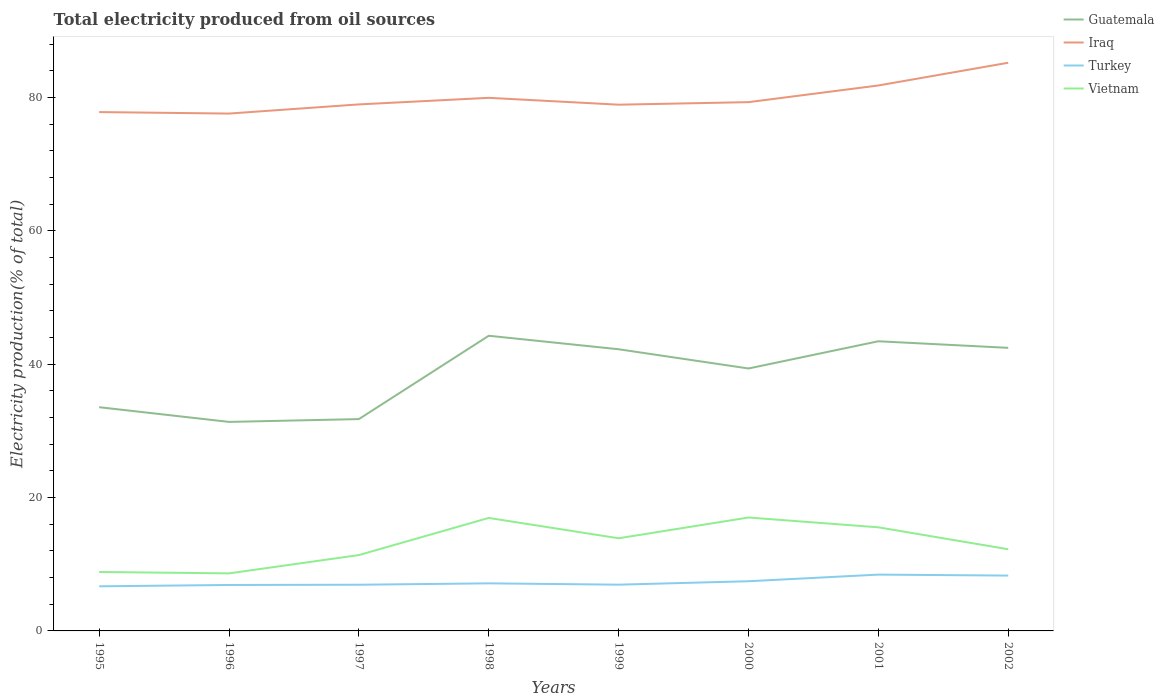How many different coloured lines are there?
Make the answer very short. 4. Is the number of lines equal to the number of legend labels?
Provide a succinct answer. Yes. Across all years, what is the maximum total electricity produced in Guatemala?
Offer a very short reply. 31.36. In which year was the total electricity produced in Guatemala maximum?
Provide a succinct answer. 1996. What is the total total electricity produced in Guatemala in the graph?
Ensure brevity in your answer.  -0.21. What is the difference between the highest and the second highest total electricity produced in Vietnam?
Offer a very short reply. 8.38. How many lines are there?
Your answer should be compact. 4. How many years are there in the graph?
Your answer should be very brief. 8. Are the values on the major ticks of Y-axis written in scientific E-notation?
Offer a very short reply. No. Does the graph contain grids?
Give a very brief answer. No. How are the legend labels stacked?
Offer a terse response. Vertical. What is the title of the graph?
Your answer should be very brief. Total electricity produced from oil sources. What is the label or title of the X-axis?
Offer a terse response. Years. What is the Electricity production(% of total) in Guatemala in 1995?
Your answer should be very brief. 33.56. What is the Electricity production(% of total) in Iraq in 1995?
Make the answer very short. 77.83. What is the Electricity production(% of total) in Turkey in 1995?
Your answer should be compact. 6.69. What is the Electricity production(% of total) in Vietnam in 1995?
Provide a short and direct response. 8.84. What is the Electricity production(% of total) of Guatemala in 1996?
Make the answer very short. 31.36. What is the Electricity production(% of total) of Iraq in 1996?
Provide a succinct answer. 77.61. What is the Electricity production(% of total) in Turkey in 1996?
Provide a short and direct response. 6.89. What is the Electricity production(% of total) in Vietnam in 1996?
Provide a short and direct response. 8.63. What is the Electricity production(% of total) in Guatemala in 1997?
Offer a very short reply. 31.78. What is the Electricity production(% of total) in Iraq in 1997?
Your answer should be compact. 78.98. What is the Electricity production(% of total) of Turkey in 1997?
Your answer should be compact. 6.93. What is the Electricity production(% of total) in Vietnam in 1997?
Your answer should be very brief. 11.38. What is the Electricity production(% of total) of Guatemala in 1998?
Give a very brief answer. 44.28. What is the Electricity production(% of total) of Iraq in 1998?
Offer a terse response. 79.97. What is the Electricity production(% of total) of Turkey in 1998?
Your response must be concise. 7.14. What is the Electricity production(% of total) in Vietnam in 1998?
Provide a short and direct response. 16.95. What is the Electricity production(% of total) in Guatemala in 1999?
Keep it short and to the point. 42.25. What is the Electricity production(% of total) of Iraq in 1999?
Your response must be concise. 78.94. What is the Electricity production(% of total) of Turkey in 1999?
Keep it short and to the point. 6.94. What is the Electricity production(% of total) in Vietnam in 1999?
Provide a succinct answer. 13.9. What is the Electricity production(% of total) of Guatemala in 2000?
Your answer should be very brief. 39.37. What is the Electricity production(% of total) in Iraq in 2000?
Ensure brevity in your answer.  79.32. What is the Electricity production(% of total) of Turkey in 2000?
Offer a terse response. 7.45. What is the Electricity production(% of total) of Vietnam in 2000?
Your answer should be compact. 17.01. What is the Electricity production(% of total) in Guatemala in 2001?
Offer a very short reply. 43.45. What is the Electricity production(% of total) of Iraq in 2001?
Your answer should be very brief. 81.82. What is the Electricity production(% of total) in Turkey in 2001?
Provide a short and direct response. 8.45. What is the Electricity production(% of total) of Vietnam in 2001?
Offer a terse response. 15.54. What is the Electricity production(% of total) in Guatemala in 2002?
Ensure brevity in your answer.  42.46. What is the Electricity production(% of total) in Iraq in 2002?
Keep it short and to the point. 85.23. What is the Electricity production(% of total) in Turkey in 2002?
Make the answer very short. 8.3. What is the Electricity production(% of total) in Vietnam in 2002?
Provide a succinct answer. 12.25. Across all years, what is the maximum Electricity production(% of total) of Guatemala?
Ensure brevity in your answer.  44.28. Across all years, what is the maximum Electricity production(% of total) in Iraq?
Your answer should be compact. 85.23. Across all years, what is the maximum Electricity production(% of total) in Turkey?
Keep it short and to the point. 8.45. Across all years, what is the maximum Electricity production(% of total) of Vietnam?
Keep it short and to the point. 17.01. Across all years, what is the minimum Electricity production(% of total) of Guatemala?
Offer a very short reply. 31.36. Across all years, what is the minimum Electricity production(% of total) of Iraq?
Give a very brief answer. 77.61. Across all years, what is the minimum Electricity production(% of total) in Turkey?
Offer a very short reply. 6.69. Across all years, what is the minimum Electricity production(% of total) of Vietnam?
Provide a short and direct response. 8.63. What is the total Electricity production(% of total) of Guatemala in the graph?
Provide a succinct answer. 308.51. What is the total Electricity production(% of total) of Iraq in the graph?
Provide a succinct answer. 639.72. What is the total Electricity production(% of total) in Turkey in the graph?
Offer a terse response. 58.79. What is the total Electricity production(% of total) of Vietnam in the graph?
Keep it short and to the point. 104.51. What is the difference between the Electricity production(% of total) in Guatemala in 1995 and that in 1996?
Provide a succinct answer. 2.2. What is the difference between the Electricity production(% of total) in Iraq in 1995 and that in 1996?
Your response must be concise. 0.22. What is the difference between the Electricity production(% of total) in Turkey in 1995 and that in 1996?
Offer a terse response. -0.2. What is the difference between the Electricity production(% of total) of Vietnam in 1995 and that in 1996?
Your answer should be compact. 0.21. What is the difference between the Electricity production(% of total) of Guatemala in 1995 and that in 1997?
Keep it short and to the point. 1.78. What is the difference between the Electricity production(% of total) of Iraq in 1995 and that in 1997?
Offer a terse response. -1.15. What is the difference between the Electricity production(% of total) of Turkey in 1995 and that in 1997?
Provide a succinct answer. -0.24. What is the difference between the Electricity production(% of total) in Vietnam in 1995 and that in 1997?
Provide a succinct answer. -2.54. What is the difference between the Electricity production(% of total) of Guatemala in 1995 and that in 1998?
Make the answer very short. -10.72. What is the difference between the Electricity production(% of total) of Iraq in 1995 and that in 1998?
Ensure brevity in your answer.  -2.14. What is the difference between the Electricity production(% of total) in Turkey in 1995 and that in 1998?
Provide a succinct answer. -0.44. What is the difference between the Electricity production(% of total) in Vietnam in 1995 and that in 1998?
Your response must be concise. -8.11. What is the difference between the Electricity production(% of total) of Guatemala in 1995 and that in 1999?
Your answer should be very brief. -8.69. What is the difference between the Electricity production(% of total) in Iraq in 1995 and that in 1999?
Your answer should be compact. -1.11. What is the difference between the Electricity production(% of total) of Turkey in 1995 and that in 1999?
Make the answer very short. -0.25. What is the difference between the Electricity production(% of total) of Vietnam in 1995 and that in 1999?
Make the answer very short. -5.06. What is the difference between the Electricity production(% of total) in Guatemala in 1995 and that in 2000?
Make the answer very short. -5.81. What is the difference between the Electricity production(% of total) of Iraq in 1995 and that in 2000?
Your answer should be compact. -1.49. What is the difference between the Electricity production(% of total) of Turkey in 1995 and that in 2000?
Your response must be concise. -0.76. What is the difference between the Electricity production(% of total) of Vietnam in 1995 and that in 2000?
Ensure brevity in your answer.  -8.17. What is the difference between the Electricity production(% of total) in Guatemala in 1995 and that in 2001?
Your answer should be compact. -9.89. What is the difference between the Electricity production(% of total) in Iraq in 1995 and that in 2001?
Your response must be concise. -3.99. What is the difference between the Electricity production(% of total) in Turkey in 1995 and that in 2001?
Offer a very short reply. -1.75. What is the difference between the Electricity production(% of total) in Vietnam in 1995 and that in 2001?
Offer a terse response. -6.7. What is the difference between the Electricity production(% of total) of Guatemala in 1995 and that in 2002?
Your answer should be very brief. -8.9. What is the difference between the Electricity production(% of total) of Iraq in 1995 and that in 2002?
Provide a succinct answer. -7.4. What is the difference between the Electricity production(% of total) of Turkey in 1995 and that in 2002?
Offer a very short reply. -1.61. What is the difference between the Electricity production(% of total) in Vietnam in 1995 and that in 2002?
Keep it short and to the point. -3.41. What is the difference between the Electricity production(% of total) in Guatemala in 1996 and that in 1997?
Ensure brevity in your answer.  -0.42. What is the difference between the Electricity production(% of total) in Iraq in 1996 and that in 1997?
Your answer should be compact. -1.37. What is the difference between the Electricity production(% of total) in Turkey in 1996 and that in 1997?
Give a very brief answer. -0.03. What is the difference between the Electricity production(% of total) of Vietnam in 1996 and that in 1997?
Provide a short and direct response. -2.74. What is the difference between the Electricity production(% of total) of Guatemala in 1996 and that in 1998?
Ensure brevity in your answer.  -12.92. What is the difference between the Electricity production(% of total) of Iraq in 1996 and that in 1998?
Your response must be concise. -2.36. What is the difference between the Electricity production(% of total) in Turkey in 1996 and that in 1998?
Your response must be concise. -0.24. What is the difference between the Electricity production(% of total) in Vietnam in 1996 and that in 1998?
Provide a succinct answer. -8.32. What is the difference between the Electricity production(% of total) in Guatemala in 1996 and that in 1999?
Provide a short and direct response. -10.9. What is the difference between the Electricity production(% of total) in Iraq in 1996 and that in 1999?
Offer a very short reply. -1.33. What is the difference between the Electricity production(% of total) in Turkey in 1996 and that in 1999?
Offer a terse response. -0.04. What is the difference between the Electricity production(% of total) of Vietnam in 1996 and that in 1999?
Your answer should be compact. -5.26. What is the difference between the Electricity production(% of total) of Guatemala in 1996 and that in 2000?
Provide a short and direct response. -8.01. What is the difference between the Electricity production(% of total) in Iraq in 1996 and that in 2000?
Your answer should be very brief. -1.71. What is the difference between the Electricity production(% of total) in Turkey in 1996 and that in 2000?
Offer a terse response. -0.56. What is the difference between the Electricity production(% of total) in Vietnam in 1996 and that in 2000?
Your answer should be very brief. -8.38. What is the difference between the Electricity production(% of total) in Guatemala in 1996 and that in 2001?
Make the answer very short. -12.1. What is the difference between the Electricity production(% of total) of Iraq in 1996 and that in 2001?
Ensure brevity in your answer.  -4.21. What is the difference between the Electricity production(% of total) in Turkey in 1996 and that in 2001?
Your answer should be compact. -1.55. What is the difference between the Electricity production(% of total) of Vietnam in 1996 and that in 2001?
Provide a succinct answer. -6.91. What is the difference between the Electricity production(% of total) of Guatemala in 1996 and that in 2002?
Ensure brevity in your answer.  -11.11. What is the difference between the Electricity production(% of total) of Iraq in 1996 and that in 2002?
Your answer should be compact. -7.62. What is the difference between the Electricity production(% of total) of Turkey in 1996 and that in 2002?
Make the answer very short. -1.41. What is the difference between the Electricity production(% of total) in Vietnam in 1996 and that in 2002?
Keep it short and to the point. -3.62. What is the difference between the Electricity production(% of total) in Guatemala in 1997 and that in 1998?
Your response must be concise. -12.5. What is the difference between the Electricity production(% of total) in Iraq in 1997 and that in 1998?
Ensure brevity in your answer.  -0.99. What is the difference between the Electricity production(% of total) in Turkey in 1997 and that in 1998?
Give a very brief answer. -0.21. What is the difference between the Electricity production(% of total) of Vietnam in 1997 and that in 1998?
Provide a short and direct response. -5.57. What is the difference between the Electricity production(% of total) of Guatemala in 1997 and that in 1999?
Make the answer very short. -10.48. What is the difference between the Electricity production(% of total) of Iraq in 1997 and that in 1999?
Make the answer very short. 0.04. What is the difference between the Electricity production(% of total) of Turkey in 1997 and that in 1999?
Give a very brief answer. -0.01. What is the difference between the Electricity production(% of total) of Vietnam in 1997 and that in 1999?
Your response must be concise. -2.52. What is the difference between the Electricity production(% of total) of Guatemala in 1997 and that in 2000?
Give a very brief answer. -7.59. What is the difference between the Electricity production(% of total) of Iraq in 1997 and that in 2000?
Ensure brevity in your answer.  -0.34. What is the difference between the Electricity production(% of total) in Turkey in 1997 and that in 2000?
Give a very brief answer. -0.52. What is the difference between the Electricity production(% of total) in Vietnam in 1997 and that in 2000?
Offer a terse response. -5.63. What is the difference between the Electricity production(% of total) in Guatemala in 1997 and that in 2001?
Your answer should be very brief. -11.67. What is the difference between the Electricity production(% of total) in Iraq in 1997 and that in 2001?
Offer a terse response. -2.84. What is the difference between the Electricity production(% of total) in Turkey in 1997 and that in 2001?
Your answer should be very brief. -1.52. What is the difference between the Electricity production(% of total) in Vietnam in 1997 and that in 2001?
Offer a very short reply. -4.16. What is the difference between the Electricity production(% of total) in Guatemala in 1997 and that in 2002?
Provide a short and direct response. -10.69. What is the difference between the Electricity production(% of total) of Iraq in 1997 and that in 2002?
Keep it short and to the point. -6.25. What is the difference between the Electricity production(% of total) in Turkey in 1997 and that in 2002?
Your answer should be compact. -1.37. What is the difference between the Electricity production(% of total) in Vietnam in 1997 and that in 2002?
Provide a succinct answer. -0.87. What is the difference between the Electricity production(% of total) in Guatemala in 1998 and that in 1999?
Your answer should be very brief. 2.02. What is the difference between the Electricity production(% of total) in Iraq in 1998 and that in 1999?
Give a very brief answer. 1.03. What is the difference between the Electricity production(% of total) in Turkey in 1998 and that in 1999?
Offer a very short reply. 0.2. What is the difference between the Electricity production(% of total) of Vietnam in 1998 and that in 1999?
Provide a short and direct response. 3.05. What is the difference between the Electricity production(% of total) in Guatemala in 1998 and that in 2000?
Ensure brevity in your answer.  4.91. What is the difference between the Electricity production(% of total) in Iraq in 1998 and that in 2000?
Ensure brevity in your answer.  0.65. What is the difference between the Electricity production(% of total) of Turkey in 1998 and that in 2000?
Provide a succinct answer. -0.32. What is the difference between the Electricity production(% of total) in Vietnam in 1998 and that in 2000?
Your answer should be very brief. -0.06. What is the difference between the Electricity production(% of total) in Guatemala in 1998 and that in 2001?
Your answer should be compact. 0.83. What is the difference between the Electricity production(% of total) in Iraq in 1998 and that in 2001?
Ensure brevity in your answer.  -1.85. What is the difference between the Electricity production(% of total) in Turkey in 1998 and that in 2001?
Make the answer very short. -1.31. What is the difference between the Electricity production(% of total) of Vietnam in 1998 and that in 2001?
Your response must be concise. 1.41. What is the difference between the Electricity production(% of total) in Guatemala in 1998 and that in 2002?
Make the answer very short. 1.81. What is the difference between the Electricity production(% of total) of Iraq in 1998 and that in 2002?
Make the answer very short. -5.26. What is the difference between the Electricity production(% of total) in Turkey in 1998 and that in 2002?
Give a very brief answer. -1.17. What is the difference between the Electricity production(% of total) in Vietnam in 1998 and that in 2002?
Provide a succinct answer. 4.7. What is the difference between the Electricity production(% of total) of Guatemala in 1999 and that in 2000?
Provide a succinct answer. 2.89. What is the difference between the Electricity production(% of total) of Iraq in 1999 and that in 2000?
Give a very brief answer. -0.38. What is the difference between the Electricity production(% of total) of Turkey in 1999 and that in 2000?
Provide a succinct answer. -0.52. What is the difference between the Electricity production(% of total) of Vietnam in 1999 and that in 2000?
Keep it short and to the point. -3.12. What is the difference between the Electricity production(% of total) of Guatemala in 1999 and that in 2001?
Your answer should be compact. -1.2. What is the difference between the Electricity production(% of total) in Iraq in 1999 and that in 2001?
Provide a succinct answer. -2.88. What is the difference between the Electricity production(% of total) of Turkey in 1999 and that in 2001?
Your answer should be compact. -1.51. What is the difference between the Electricity production(% of total) of Vietnam in 1999 and that in 2001?
Ensure brevity in your answer.  -1.64. What is the difference between the Electricity production(% of total) in Guatemala in 1999 and that in 2002?
Make the answer very short. -0.21. What is the difference between the Electricity production(% of total) in Iraq in 1999 and that in 2002?
Provide a succinct answer. -6.29. What is the difference between the Electricity production(% of total) of Turkey in 1999 and that in 2002?
Your answer should be very brief. -1.36. What is the difference between the Electricity production(% of total) in Vietnam in 1999 and that in 2002?
Keep it short and to the point. 1.64. What is the difference between the Electricity production(% of total) of Guatemala in 2000 and that in 2001?
Provide a short and direct response. -4.08. What is the difference between the Electricity production(% of total) in Iraq in 2000 and that in 2001?
Keep it short and to the point. -2.5. What is the difference between the Electricity production(% of total) in Turkey in 2000 and that in 2001?
Provide a short and direct response. -0.99. What is the difference between the Electricity production(% of total) in Vietnam in 2000 and that in 2001?
Make the answer very short. 1.47. What is the difference between the Electricity production(% of total) in Guatemala in 2000 and that in 2002?
Make the answer very short. -3.1. What is the difference between the Electricity production(% of total) of Iraq in 2000 and that in 2002?
Give a very brief answer. -5.91. What is the difference between the Electricity production(% of total) of Turkey in 2000 and that in 2002?
Offer a terse response. -0.85. What is the difference between the Electricity production(% of total) of Vietnam in 2000 and that in 2002?
Ensure brevity in your answer.  4.76. What is the difference between the Electricity production(% of total) of Guatemala in 2001 and that in 2002?
Keep it short and to the point. 0.99. What is the difference between the Electricity production(% of total) in Iraq in 2001 and that in 2002?
Offer a terse response. -3.41. What is the difference between the Electricity production(% of total) in Turkey in 2001 and that in 2002?
Ensure brevity in your answer.  0.14. What is the difference between the Electricity production(% of total) of Vietnam in 2001 and that in 2002?
Make the answer very short. 3.29. What is the difference between the Electricity production(% of total) of Guatemala in 1995 and the Electricity production(% of total) of Iraq in 1996?
Give a very brief answer. -44.05. What is the difference between the Electricity production(% of total) of Guatemala in 1995 and the Electricity production(% of total) of Turkey in 1996?
Make the answer very short. 26.67. What is the difference between the Electricity production(% of total) in Guatemala in 1995 and the Electricity production(% of total) in Vietnam in 1996?
Make the answer very short. 24.93. What is the difference between the Electricity production(% of total) of Iraq in 1995 and the Electricity production(% of total) of Turkey in 1996?
Keep it short and to the point. 70.94. What is the difference between the Electricity production(% of total) of Iraq in 1995 and the Electricity production(% of total) of Vietnam in 1996?
Make the answer very short. 69.2. What is the difference between the Electricity production(% of total) in Turkey in 1995 and the Electricity production(% of total) in Vietnam in 1996?
Provide a short and direct response. -1.94. What is the difference between the Electricity production(% of total) in Guatemala in 1995 and the Electricity production(% of total) in Iraq in 1997?
Your response must be concise. -45.42. What is the difference between the Electricity production(% of total) in Guatemala in 1995 and the Electricity production(% of total) in Turkey in 1997?
Provide a succinct answer. 26.63. What is the difference between the Electricity production(% of total) of Guatemala in 1995 and the Electricity production(% of total) of Vietnam in 1997?
Offer a terse response. 22.18. What is the difference between the Electricity production(% of total) in Iraq in 1995 and the Electricity production(% of total) in Turkey in 1997?
Your response must be concise. 70.9. What is the difference between the Electricity production(% of total) in Iraq in 1995 and the Electricity production(% of total) in Vietnam in 1997?
Provide a short and direct response. 66.45. What is the difference between the Electricity production(% of total) in Turkey in 1995 and the Electricity production(% of total) in Vietnam in 1997?
Your answer should be compact. -4.69. What is the difference between the Electricity production(% of total) in Guatemala in 1995 and the Electricity production(% of total) in Iraq in 1998?
Your answer should be compact. -46.41. What is the difference between the Electricity production(% of total) in Guatemala in 1995 and the Electricity production(% of total) in Turkey in 1998?
Offer a terse response. 26.42. What is the difference between the Electricity production(% of total) in Guatemala in 1995 and the Electricity production(% of total) in Vietnam in 1998?
Offer a very short reply. 16.61. What is the difference between the Electricity production(% of total) in Iraq in 1995 and the Electricity production(% of total) in Turkey in 1998?
Ensure brevity in your answer.  70.7. What is the difference between the Electricity production(% of total) in Iraq in 1995 and the Electricity production(% of total) in Vietnam in 1998?
Give a very brief answer. 60.88. What is the difference between the Electricity production(% of total) in Turkey in 1995 and the Electricity production(% of total) in Vietnam in 1998?
Keep it short and to the point. -10.26. What is the difference between the Electricity production(% of total) of Guatemala in 1995 and the Electricity production(% of total) of Iraq in 1999?
Make the answer very short. -45.38. What is the difference between the Electricity production(% of total) in Guatemala in 1995 and the Electricity production(% of total) in Turkey in 1999?
Give a very brief answer. 26.62. What is the difference between the Electricity production(% of total) in Guatemala in 1995 and the Electricity production(% of total) in Vietnam in 1999?
Provide a short and direct response. 19.66. What is the difference between the Electricity production(% of total) in Iraq in 1995 and the Electricity production(% of total) in Turkey in 1999?
Your response must be concise. 70.9. What is the difference between the Electricity production(% of total) in Iraq in 1995 and the Electricity production(% of total) in Vietnam in 1999?
Provide a short and direct response. 63.94. What is the difference between the Electricity production(% of total) in Turkey in 1995 and the Electricity production(% of total) in Vietnam in 1999?
Ensure brevity in your answer.  -7.2. What is the difference between the Electricity production(% of total) of Guatemala in 1995 and the Electricity production(% of total) of Iraq in 2000?
Your answer should be compact. -45.76. What is the difference between the Electricity production(% of total) in Guatemala in 1995 and the Electricity production(% of total) in Turkey in 2000?
Provide a succinct answer. 26.11. What is the difference between the Electricity production(% of total) of Guatemala in 1995 and the Electricity production(% of total) of Vietnam in 2000?
Offer a terse response. 16.55. What is the difference between the Electricity production(% of total) in Iraq in 1995 and the Electricity production(% of total) in Turkey in 2000?
Keep it short and to the point. 70.38. What is the difference between the Electricity production(% of total) of Iraq in 1995 and the Electricity production(% of total) of Vietnam in 2000?
Offer a very short reply. 60.82. What is the difference between the Electricity production(% of total) in Turkey in 1995 and the Electricity production(% of total) in Vietnam in 2000?
Offer a terse response. -10.32. What is the difference between the Electricity production(% of total) in Guatemala in 1995 and the Electricity production(% of total) in Iraq in 2001?
Give a very brief answer. -48.26. What is the difference between the Electricity production(% of total) in Guatemala in 1995 and the Electricity production(% of total) in Turkey in 2001?
Your response must be concise. 25.11. What is the difference between the Electricity production(% of total) of Guatemala in 1995 and the Electricity production(% of total) of Vietnam in 2001?
Your answer should be very brief. 18.02. What is the difference between the Electricity production(% of total) in Iraq in 1995 and the Electricity production(% of total) in Turkey in 2001?
Give a very brief answer. 69.39. What is the difference between the Electricity production(% of total) in Iraq in 1995 and the Electricity production(% of total) in Vietnam in 2001?
Give a very brief answer. 62.29. What is the difference between the Electricity production(% of total) of Turkey in 1995 and the Electricity production(% of total) of Vietnam in 2001?
Give a very brief answer. -8.85. What is the difference between the Electricity production(% of total) of Guatemala in 1995 and the Electricity production(% of total) of Iraq in 2002?
Offer a terse response. -51.67. What is the difference between the Electricity production(% of total) in Guatemala in 1995 and the Electricity production(% of total) in Turkey in 2002?
Provide a short and direct response. 25.26. What is the difference between the Electricity production(% of total) in Guatemala in 1995 and the Electricity production(% of total) in Vietnam in 2002?
Provide a short and direct response. 21.31. What is the difference between the Electricity production(% of total) of Iraq in 1995 and the Electricity production(% of total) of Turkey in 2002?
Ensure brevity in your answer.  69.53. What is the difference between the Electricity production(% of total) of Iraq in 1995 and the Electricity production(% of total) of Vietnam in 2002?
Your answer should be very brief. 65.58. What is the difference between the Electricity production(% of total) of Turkey in 1995 and the Electricity production(% of total) of Vietnam in 2002?
Provide a short and direct response. -5.56. What is the difference between the Electricity production(% of total) in Guatemala in 1996 and the Electricity production(% of total) in Iraq in 1997?
Make the answer very short. -47.63. What is the difference between the Electricity production(% of total) of Guatemala in 1996 and the Electricity production(% of total) of Turkey in 1997?
Your answer should be very brief. 24.43. What is the difference between the Electricity production(% of total) of Guatemala in 1996 and the Electricity production(% of total) of Vietnam in 1997?
Offer a terse response. 19.98. What is the difference between the Electricity production(% of total) of Iraq in 1996 and the Electricity production(% of total) of Turkey in 1997?
Your answer should be compact. 70.68. What is the difference between the Electricity production(% of total) of Iraq in 1996 and the Electricity production(% of total) of Vietnam in 1997?
Make the answer very short. 66.23. What is the difference between the Electricity production(% of total) in Turkey in 1996 and the Electricity production(% of total) in Vietnam in 1997?
Provide a succinct answer. -4.48. What is the difference between the Electricity production(% of total) in Guatemala in 1996 and the Electricity production(% of total) in Iraq in 1998?
Your response must be concise. -48.62. What is the difference between the Electricity production(% of total) in Guatemala in 1996 and the Electricity production(% of total) in Turkey in 1998?
Provide a succinct answer. 24.22. What is the difference between the Electricity production(% of total) in Guatemala in 1996 and the Electricity production(% of total) in Vietnam in 1998?
Keep it short and to the point. 14.41. What is the difference between the Electricity production(% of total) in Iraq in 1996 and the Electricity production(% of total) in Turkey in 1998?
Your answer should be compact. 70.47. What is the difference between the Electricity production(% of total) of Iraq in 1996 and the Electricity production(% of total) of Vietnam in 1998?
Your answer should be very brief. 60.66. What is the difference between the Electricity production(% of total) in Turkey in 1996 and the Electricity production(% of total) in Vietnam in 1998?
Your answer should be very brief. -10.06. What is the difference between the Electricity production(% of total) in Guatemala in 1996 and the Electricity production(% of total) in Iraq in 1999?
Ensure brevity in your answer.  -47.58. What is the difference between the Electricity production(% of total) of Guatemala in 1996 and the Electricity production(% of total) of Turkey in 1999?
Provide a short and direct response. 24.42. What is the difference between the Electricity production(% of total) in Guatemala in 1996 and the Electricity production(% of total) in Vietnam in 1999?
Your answer should be very brief. 17.46. What is the difference between the Electricity production(% of total) in Iraq in 1996 and the Electricity production(% of total) in Turkey in 1999?
Provide a succinct answer. 70.67. What is the difference between the Electricity production(% of total) of Iraq in 1996 and the Electricity production(% of total) of Vietnam in 1999?
Provide a short and direct response. 63.71. What is the difference between the Electricity production(% of total) in Turkey in 1996 and the Electricity production(% of total) in Vietnam in 1999?
Provide a succinct answer. -7. What is the difference between the Electricity production(% of total) in Guatemala in 1996 and the Electricity production(% of total) in Iraq in 2000?
Offer a very short reply. -47.97. What is the difference between the Electricity production(% of total) of Guatemala in 1996 and the Electricity production(% of total) of Turkey in 2000?
Your answer should be very brief. 23.9. What is the difference between the Electricity production(% of total) of Guatemala in 1996 and the Electricity production(% of total) of Vietnam in 2000?
Give a very brief answer. 14.34. What is the difference between the Electricity production(% of total) in Iraq in 1996 and the Electricity production(% of total) in Turkey in 2000?
Your answer should be very brief. 70.16. What is the difference between the Electricity production(% of total) of Iraq in 1996 and the Electricity production(% of total) of Vietnam in 2000?
Your answer should be very brief. 60.6. What is the difference between the Electricity production(% of total) in Turkey in 1996 and the Electricity production(% of total) in Vietnam in 2000?
Provide a succinct answer. -10.12. What is the difference between the Electricity production(% of total) in Guatemala in 1996 and the Electricity production(% of total) in Iraq in 2001?
Your answer should be very brief. -50.47. What is the difference between the Electricity production(% of total) of Guatemala in 1996 and the Electricity production(% of total) of Turkey in 2001?
Your answer should be compact. 22.91. What is the difference between the Electricity production(% of total) in Guatemala in 1996 and the Electricity production(% of total) in Vietnam in 2001?
Provide a succinct answer. 15.81. What is the difference between the Electricity production(% of total) in Iraq in 1996 and the Electricity production(% of total) in Turkey in 2001?
Keep it short and to the point. 69.16. What is the difference between the Electricity production(% of total) in Iraq in 1996 and the Electricity production(% of total) in Vietnam in 2001?
Your answer should be very brief. 62.07. What is the difference between the Electricity production(% of total) of Turkey in 1996 and the Electricity production(% of total) of Vietnam in 2001?
Give a very brief answer. -8.65. What is the difference between the Electricity production(% of total) in Guatemala in 1996 and the Electricity production(% of total) in Iraq in 2002?
Your answer should be very brief. -53.88. What is the difference between the Electricity production(% of total) in Guatemala in 1996 and the Electricity production(% of total) in Turkey in 2002?
Keep it short and to the point. 23.05. What is the difference between the Electricity production(% of total) of Guatemala in 1996 and the Electricity production(% of total) of Vietnam in 2002?
Offer a terse response. 19.1. What is the difference between the Electricity production(% of total) of Iraq in 1996 and the Electricity production(% of total) of Turkey in 2002?
Give a very brief answer. 69.31. What is the difference between the Electricity production(% of total) in Iraq in 1996 and the Electricity production(% of total) in Vietnam in 2002?
Provide a short and direct response. 65.36. What is the difference between the Electricity production(% of total) in Turkey in 1996 and the Electricity production(% of total) in Vietnam in 2002?
Provide a short and direct response. -5.36. What is the difference between the Electricity production(% of total) of Guatemala in 1997 and the Electricity production(% of total) of Iraq in 1998?
Provide a short and direct response. -48.19. What is the difference between the Electricity production(% of total) of Guatemala in 1997 and the Electricity production(% of total) of Turkey in 1998?
Your answer should be compact. 24.64. What is the difference between the Electricity production(% of total) of Guatemala in 1997 and the Electricity production(% of total) of Vietnam in 1998?
Make the answer very short. 14.83. What is the difference between the Electricity production(% of total) in Iraq in 1997 and the Electricity production(% of total) in Turkey in 1998?
Give a very brief answer. 71.85. What is the difference between the Electricity production(% of total) of Iraq in 1997 and the Electricity production(% of total) of Vietnam in 1998?
Your response must be concise. 62.03. What is the difference between the Electricity production(% of total) in Turkey in 1997 and the Electricity production(% of total) in Vietnam in 1998?
Keep it short and to the point. -10.02. What is the difference between the Electricity production(% of total) in Guatemala in 1997 and the Electricity production(% of total) in Iraq in 1999?
Your answer should be very brief. -47.16. What is the difference between the Electricity production(% of total) of Guatemala in 1997 and the Electricity production(% of total) of Turkey in 1999?
Make the answer very short. 24.84. What is the difference between the Electricity production(% of total) in Guatemala in 1997 and the Electricity production(% of total) in Vietnam in 1999?
Offer a very short reply. 17.88. What is the difference between the Electricity production(% of total) in Iraq in 1997 and the Electricity production(% of total) in Turkey in 1999?
Ensure brevity in your answer.  72.05. What is the difference between the Electricity production(% of total) in Iraq in 1997 and the Electricity production(% of total) in Vietnam in 1999?
Offer a very short reply. 65.09. What is the difference between the Electricity production(% of total) in Turkey in 1997 and the Electricity production(% of total) in Vietnam in 1999?
Give a very brief answer. -6.97. What is the difference between the Electricity production(% of total) in Guatemala in 1997 and the Electricity production(% of total) in Iraq in 2000?
Your response must be concise. -47.55. What is the difference between the Electricity production(% of total) in Guatemala in 1997 and the Electricity production(% of total) in Turkey in 2000?
Keep it short and to the point. 24.32. What is the difference between the Electricity production(% of total) of Guatemala in 1997 and the Electricity production(% of total) of Vietnam in 2000?
Your answer should be very brief. 14.76. What is the difference between the Electricity production(% of total) of Iraq in 1997 and the Electricity production(% of total) of Turkey in 2000?
Your answer should be very brief. 71.53. What is the difference between the Electricity production(% of total) of Iraq in 1997 and the Electricity production(% of total) of Vietnam in 2000?
Make the answer very short. 61.97. What is the difference between the Electricity production(% of total) in Turkey in 1997 and the Electricity production(% of total) in Vietnam in 2000?
Offer a very short reply. -10.09. What is the difference between the Electricity production(% of total) of Guatemala in 1997 and the Electricity production(% of total) of Iraq in 2001?
Give a very brief answer. -50.05. What is the difference between the Electricity production(% of total) of Guatemala in 1997 and the Electricity production(% of total) of Turkey in 2001?
Give a very brief answer. 23.33. What is the difference between the Electricity production(% of total) in Guatemala in 1997 and the Electricity production(% of total) in Vietnam in 2001?
Provide a short and direct response. 16.24. What is the difference between the Electricity production(% of total) of Iraq in 1997 and the Electricity production(% of total) of Turkey in 2001?
Provide a succinct answer. 70.54. What is the difference between the Electricity production(% of total) of Iraq in 1997 and the Electricity production(% of total) of Vietnam in 2001?
Your answer should be very brief. 63.44. What is the difference between the Electricity production(% of total) of Turkey in 1997 and the Electricity production(% of total) of Vietnam in 2001?
Your answer should be very brief. -8.61. What is the difference between the Electricity production(% of total) in Guatemala in 1997 and the Electricity production(% of total) in Iraq in 2002?
Ensure brevity in your answer.  -53.45. What is the difference between the Electricity production(% of total) in Guatemala in 1997 and the Electricity production(% of total) in Turkey in 2002?
Make the answer very short. 23.47. What is the difference between the Electricity production(% of total) of Guatemala in 1997 and the Electricity production(% of total) of Vietnam in 2002?
Your response must be concise. 19.52. What is the difference between the Electricity production(% of total) in Iraq in 1997 and the Electricity production(% of total) in Turkey in 2002?
Your answer should be very brief. 70.68. What is the difference between the Electricity production(% of total) in Iraq in 1997 and the Electricity production(% of total) in Vietnam in 2002?
Keep it short and to the point. 66.73. What is the difference between the Electricity production(% of total) in Turkey in 1997 and the Electricity production(% of total) in Vietnam in 2002?
Keep it short and to the point. -5.32. What is the difference between the Electricity production(% of total) in Guatemala in 1998 and the Electricity production(% of total) in Iraq in 1999?
Offer a terse response. -34.66. What is the difference between the Electricity production(% of total) in Guatemala in 1998 and the Electricity production(% of total) in Turkey in 1999?
Your response must be concise. 37.34. What is the difference between the Electricity production(% of total) in Guatemala in 1998 and the Electricity production(% of total) in Vietnam in 1999?
Your answer should be very brief. 30.38. What is the difference between the Electricity production(% of total) of Iraq in 1998 and the Electricity production(% of total) of Turkey in 1999?
Give a very brief answer. 73.03. What is the difference between the Electricity production(% of total) of Iraq in 1998 and the Electricity production(% of total) of Vietnam in 1999?
Give a very brief answer. 66.07. What is the difference between the Electricity production(% of total) in Turkey in 1998 and the Electricity production(% of total) in Vietnam in 1999?
Your answer should be very brief. -6.76. What is the difference between the Electricity production(% of total) in Guatemala in 1998 and the Electricity production(% of total) in Iraq in 2000?
Ensure brevity in your answer.  -35.05. What is the difference between the Electricity production(% of total) in Guatemala in 1998 and the Electricity production(% of total) in Turkey in 2000?
Ensure brevity in your answer.  36.82. What is the difference between the Electricity production(% of total) in Guatemala in 1998 and the Electricity production(% of total) in Vietnam in 2000?
Provide a succinct answer. 27.26. What is the difference between the Electricity production(% of total) in Iraq in 1998 and the Electricity production(% of total) in Turkey in 2000?
Offer a very short reply. 72.52. What is the difference between the Electricity production(% of total) in Iraq in 1998 and the Electricity production(% of total) in Vietnam in 2000?
Your answer should be very brief. 62.96. What is the difference between the Electricity production(% of total) in Turkey in 1998 and the Electricity production(% of total) in Vietnam in 2000?
Provide a succinct answer. -9.88. What is the difference between the Electricity production(% of total) in Guatemala in 1998 and the Electricity production(% of total) in Iraq in 2001?
Your answer should be compact. -37.55. What is the difference between the Electricity production(% of total) of Guatemala in 1998 and the Electricity production(% of total) of Turkey in 2001?
Give a very brief answer. 35.83. What is the difference between the Electricity production(% of total) of Guatemala in 1998 and the Electricity production(% of total) of Vietnam in 2001?
Offer a terse response. 28.74. What is the difference between the Electricity production(% of total) of Iraq in 1998 and the Electricity production(% of total) of Turkey in 2001?
Make the answer very short. 71.52. What is the difference between the Electricity production(% of total) of Iraq in 1998 and the Electricity production(% of total) of Vietnam in 2001?
Provide a succinct answer. 64.43. What is the difference between the Electricity production(% of total) of Turkey in 1998 and the Electricity production(% of total) of Vietnam in 2001?
Your response must be concise. -8.41. What is the difference between the Electricity production(% of total) of Guatemala in 1998 and the Electricity production(% of total) of Iraq in 2002?
Keep it short and to the point. -40.95. What is the difference between the Electricity production(% of total) in Guatemala in 1998 and the Electricity production(% of total) in Turkey in 2002?
Your response must be concise. 35.97. What is the difference between the Electricity production(% of total) of Guatemala in 1998 and the Electricity production(% of total) of Vietnam in 2002?
Provide a succinct answer. 32.02. What is the difference between the Electricity production(% of total) in Iraq in 1998 and the Electricity production(% of total) in Turkey in 2002?
Ensure brevity in your answer.  71.67. What is the difference between the Electricity production(% of total) of Iraq in 1998 and the Electricity production(% of total) of Vietnam in 2002?
Provide a short and direct response. 67.72. What is the difference between the Electricity production(% of total) in Turkey in 1998 and the Electricity production(% of total) in Vietnam in 2002?
Ensure brevity in your answer.  -5.12. What is the difference between the Electricity production(% of total) of Guatemala in 1999 and the Electricity production(% of total) of Iraq in 2000?
Provide a short and direct response. -37.07. What is the difference between the Electricity production(% of total) of Guatemala in 1999 and the Electricity production(% of total) of Turkey in 2000?
Provide a short and direct response. 34.8. What is the difference between the Electricity production(% of total) in Guatemala in 1999 and the Electricity production(% of total) in Vietnam in 2000?
Ensure brevity in your answer.  25.24. What is the difference between the Electricity production(% of total) of Iraq in 1999 and the Electricity production(% of total) of Turkey in 2000?
Make the answer very short. 71.49. What is the difference between the Electricity production(% of total) of Iraq in 1999 and the Electricity production(% of total) of Vietnam in 2000?
Your response must be concise. 61.93. What is the difference between the Electricity production(% of total) of Turkey in 1999 and the Electricity production(% of total) of Vietnam in 2000?
Provide a short and direct response. -10.08. What is the difference between the Electricity production(% of total) of Guatemala in 1999 and the Electricity production(% of total) of Iraq in 2001?
Offer a very short reply. -39.57. What is the difference between the Electricity production(% of total) of Guatemala in 1999 and the Electricity production(% of total) of Turkey in 2001?
Provide a short and direct response. 33.81. What is the difference between the Electricity production(% of total) of Guatemala in 1999 and the Electricity production(% of total) of Vietnam in 2001?
Provide a succinct answer. 26.71. What is the difference between the Electricity production(% of total) in Iraq in 1999 and the Electricity production(% of total) in Turkey in 2001?
Give a very brief answer. 70.49. What is the difference between the Electricity production(% of total) in Iraq in 1999 and the Electricity production(% of total) in Vietnam in 2001?
Offer a very short reply. 63.4. What is the difference between the Electricity production(% of total) in Turkey in 1999 and the Electricity production(% of total) in Vietnam in 2001?
Offer a terse response. -8.6. What is the difference between the Electricity production(% of total) in Guatemala in 1999 and the Electricity production(% of total) in Iraq in 2002?
Keep it short and to the point. -42.98. What is the difference between the Electricity production(% of total) in Guatemala in 1999 and the Electricity production(% of total) in Turkey in 2002?
Provide a succinct answer. 33.95. What is the difference between the Electricity production(% of total) of Guatemala in 1999 and the Electricity production(% of total) of Vietnam in 2002?
Your response must be concise. 30. What is the difference between the Electricity production(% of total) of Iraq in 1999 and the Electricity production(% of total) of Turkey in 2002?
Offer a very short reply. 70.64. What is the difference between the Electricity production(% of total) in Iraq in 1999 and the Electricity production(% of total) in Vietnam in 2002?
Keep it short and to the point. 66.69. What is the difference between the Electricity production(% of total) of Turkey in 1999 and the Electricity production(% of total) of Vietnam in 2002?
Your answer should be very brief. -5.31. What is the difference between the Electricity production(% of total) in Guatemala in 2000 and the Electricity production(% of total) in Iraq in 2001?
Provide a succinct answer. -42.46. What is the difference between the Electricity production(% of total) of Guatemala in 2000 and the Electricity production(% of total) of Turkey in 2001?
Provide a short and direct response. 30.92. What is the difference between the Electricity production(% of total) in Guatemala in 2000 and the Electricity production(% of total) in Vietnam in 2001?
Provide a short and direct response. 23.83. What is the difference between the Electricity production(% of total) in Iraq in 2000 and the Electricity production(% of total) in Turkey in 2001?
Ensure brevity in your answer.  70.88. What is the difference between the Electricity production(% of total) of Iraq in 2000 and the Electricity production(% of total) of Vietnam in 2001?
Make the answer very short. 63.78. What is the difference between the Electricity production(% of total) in Turkey in 2000 and the Electricity production(% of total) in Vietnam in 2001?
Your response must be concise. -8.09. What is the difference between the Electricity production(% of total) of Guatemala in 2000 and the Electricity production(% of total) of Iraq in 2002?
Make the answer very short. -45.86. What is the difference between the Electricity production(% of total) of Guatemala in 2000 and the Electricity production(% of total) of Turkey in 2002?
Offer a terse response. 31.07. What is the difference between the Electricity production(% of total) of Guatemala in 2000 and the Electricity production(% of total) of Vietnam in 2002?
Keep it short and to the point. 27.12. What is the difference between the Electricity production(% of total) of Iraq in 2000 and the Electricity production(% of total) of Turkey in 2002?
Your answer should be compact. 71.02. What is the difference between the Electricity production(% of total) in Iraq in 2000 and the Electricity production(% of total) in Vietnam in 2002?
Provide a succinct answer. 67.07. What is the difference between the Electricity production(% of total) of Turkey in 2000 and the Electricity production(% of total) of Vietnam in 2002?
Ensure brevity in your answer.  -4.8. What is the difference between the Electricity production(% of total) in Guatemala in 2001 and the Electricity production(% of total) in Iraq in 2002?
Your answer should be compact. -41.78. What is the difference between the Electricity production(% of total) in Guatemala in 2001 and the Electricity production(% of total) in Turkey in 2002?
Give a very brief answer. 35.15. What is the difference between the Electricity production(% of total) of Guatemala in 2001 and the Electricity production(% of total) of Vietnam in 2002?
Offer a terse response. 31.2. What is the difference between the Electricity production(% of total) in Iraq in 2001 and the Electricity production(% of total) in Turkey in 2002?
Give a very brief answer. 73.52. What is the difference between the Electricity production(% of total) of Iraq in 2001 and the Electricity production(% of total) of Vietnam in 2002?
Keep it short and to the point. 69.57. What is the difference between the Electricity production(% of total) in Turkey in 2001 and the Electricity production(% of total) in Vietnam in 2002?
Offer a terse response. -3.81. What is the average Electricity production(% of total) of Guatemala per year?
Keep it short and to the point. 38.56. What is the average Electricity production(% of total) in Iraq per year?
Your answer should be compact. 79.96. What is the average Electricity production(% of total) of Turkey per year?
Provide a succinct answer. 7.35. What is the average Electricity production(% of total) in Vietnam per year?
Provide a short and direct response. 13.06. In the year 1995, what is the difference between the Electricity production(% of total) in Guatemala and Electricity production(% of total) in Iraq?
Offer a terse response. -44.27. In the year 1995, what is the difference between the Electricity production(% of total) of Guatemala and Electricity production(% of total) of Turkey?
Your response must be concise. 26.87. In the year 1995, what is the difference between the Electricity production(% of total) of Guatemala and Electricity production(% of total) of Vietnam?
Offer a very short reply. 24.72. In the year 1995, what is the difference between the Electricity production(% of total) in Iraq and Electricity production(% of total) in Turkey?
Provide a short and direct response. 71.14. In the year 1995, what is the difference between the Electricity production(% of total) of Iraq and Electricity production(% of total) of Vietnam?
Provide a succinct answer. 68.99. In the year 1995, what is the difference between the Electricity production(% of total) of Turkey and Electricity production(% of total) of Vietnam?
Your answer should be very brief. -2.15. In the year 1996, what is the difference between the Electricity production(% of total) of Guatemala and Electricity production(% of total) of Iraq?
Offer a terse response. -46.25. In the year 1996, what is the difference between the Electricity production(% of total) in Guatemala and Electricity production(% of total) in Turkey?
Offer a terse response. 24.46. In the year 1996, what is the difference between the Electricity production(% of total) in Guatemala and Electricity production(% of total) in Vietnam?
Keep it short and to the point. 22.72. In the year 1996, what is the difference between the Electricity production(% of total) in Iraq and Electricity production(% of total) in Turkey?
Make the answer very short. 70.72. In the year 1996, what is the difference between the Electricity production(% of total) in Iraq and Electricity production(% of total) in Vietnam?
Offer a terse response. 68.98. In the year 1996, what is the difference between the Electricity production(% of total) in Turkey and Electricity production(% of total) in Vietnam?
Your response must be concise. -1.74. In the year 1997, what is the difference between the Electricity production(% of total) in Guatemala and Electricity production(% of total) in Iraq?
Give a very brief answer. -47.21. In the year 1997, what is the difference between the Electricity production(% of total) in Guatemala and Electricity production(% of total) in Turkey?
Ensure brevity in your answer.  24.85. In the year 1997, what is the difference between the Electricity production(% of total) of Guatemala and Electricity production(% of total) of Vietnam?
Your answer should be compact. 20.4. In the year 1997, what is the difference between the Electricity production(% of total) in Iraq and Electricity production(% of total) in Turkey?
Keep it short and to the point. 72.06. In the year 1997, what is the difference between the Electricity production(% of total) in Iraq and Electricity production(% of total) in Vietnam?
Your answer should be compact. 67.61. In the year 1997, what is the difference between the Electricity production(% of total) in Turkey and Electricity production(% of total) in Vietnam?
Provide a short and direct response. -4.45. In the year 1998, what is the difference between the Electricity production(% of total) in Guatemala and Electricity production(% of total) in Iraq?
Offer a very short reply. -35.69. In the year 1998, what is the difference between the Electricity production(% of total) in Guatemala and Electricity production(% of total) in Turkey?
Your response must be concise. 37.14. In the year 1998, what is the difference between the Electricity production(% of total) in Guatemala and Electricity production(% of total) in Vietnam?
Provide a short and direct response. 27.33. In the year 1998, what is the difference between the Electricity production(% of total) in Iraq and Electricity production(% of total) in Turkey?
Your response must be concise. 72.83. In the year 1998, what is the difference between the Electricity production(% of total) in Iraq and Electricity production(% of total) in Vietnam?
Your answer should be compact. 63.02. In the year 1998, what is the difference between the Electricity production(% of total) of Turkey and Electricity production(% of total) of Vietnam?
Make the answer very short. -9.81. In the year 1999, what is the difference between the Electricity production(% of total) in Guatemala and Electricity production(% of total) in Iraq?
Provide a succinct answer. -36.69. In the year 1999, what is the difference between the Electricity production(% of total) of Guatemala and Electricity production(% of total) of Turkey?
Provide a succinct answer. 35.32. In the year 1999, what is the difference between the Electricity production(% of total) in Guatemala and Electricity production(% of total) in Vietnam?
Keep it short and to the point. 28.36. In the year 1999, what is the difference between the Electricity production(% of total) of Iraq and Electricity production(% of total) of Turkey?
Give a very brief answer. 72. In the year 1999, what is the difference between the Electricity production(% of total) in Iraq and Electricity production(% of total) in Vietnam?
Offer a terse response. 65.04. In the year 1999, what is the difference between the Electricity production(% of total) of Turkey and Electricity production(% of total) of Vietnam?
Provide a short and direct response. -6.96. In the year 2000, what is the difference between the Electricity production(% of total) of Guatemala and Electricity production(% of total) of Iraq?
Your answer should be very brief. -39.95. In the year 2000, what is the difference between the Electricity production(% of total) of Guatemala and Electricity production(% of total) of Turkey?
Provide a succinct answer. 31.91. In the year 2000, what is the difference between the Electricity production(% of total) of Guatemala and Electricity production(% of total) of Vietnam?
Make the answer very short. 22.35. In the year 2000, what is the difference between the Electricity production(% of total) in Iraq and Electricity production(% of total) in Turkey?
Provide a short and direct response. 71.87. In the year 2000, what is the difference between the Electricity production(% of total) of Iraq and Electricity production(% of total) of Vietnam?
Give a very brief answer. 62.31. In the year 2000, what is the difference between the Electricity production(% of total) in Turkey and Electricity production(% of total) in Vietnam?
Keep it short and to the point. -9.56. In the year 2001, what is the difference between the Electricity production(% of total) in Guatemala and Electricity production(% of total) in Iraq?
Ensure brevity in your answer.  -38.37. In the year 2001, what is the difference between the Electricity production(% of total) of Guatemala and Electricity production(% of total) of Turkey?
Your response must be concise. 35. In the year 2001, what is the difference between the Electricity production(% of total) in Guatemala and Electricity production(% of total) in Vietnam?
Provide a succinct answer. 27.91. In the year 2001, what is the difference between the Electricity production(% of total) in Iraq and Electricity production(% of total) in Turkey?
Your response must be concise. 73.38. In the year 2001, what is the difference between the Electricity production(% of total) in Iraq and Electricity production(% of total) in Vietnam?
Make the answer very short. 66.28. In the year 2001, what is the difference between the Electricity production(% of total) in Turkey and Electricity production(% of total) in Vietnam?
Make the answer very short. -7.09. In the year 2002, what is the difference between the Electricity production(% of total) of Guatemala and Electricity production(% of total) of Iraq?
Your response must be concise. -42.77. In the year 2002, what is the difference between the Electricity production(% of total) of Guatemala and Electricity production(% of total) of Turkey?
Offer a very short reply. 34.16. In the year 2002, what is the difference between the Electricity production(% of total) in Guatemala and Electricity production(% of total) in Vietnam?
Your answer should be very brief. 30.21. In the year 2002, what is the difference between the Electricity production(% of total) in Iraq and Electricity production(% of total) in Turkey?
Ensure brevity in your answer.  76.93. In the year 2002, what is the difference between the Electricity production(% of total) in Iraq and Electricity production(% of total) in Vietnam?
Your answer should be very brief. 72.98. In the year 2002, what is the difference between the Electricity production(% of total) of Turkey and Electricity production(% of total) of Vietnam?
Your answer should be compact. -3.95. What is the ratio of the Electricity production(% of total) in Guatemala in 1995 to that in 1996?
Keep it short and to the point. 1.07. What is the ratio of the Electricity production(% of total) of Iraq in 1995 to that in 1996?
Give a very brief answer. 1. What is the ratio of the Electricity production(% of total) in Turkey in 1995 to that in 1996?
Offer a terse response. 0.97. What is the ratio of the Electricity production(% of total) in Vietnam in 1995 to that in 1996?
Keep it short and to the point. 1.02. What is the ratio of the Electricity production(% of total) in Guatemala in 1995 to that in 1997?
Ensure brevity in your answer.  1.06. What is the ratio of the Electricity production(% of total) in Iraq in 1995 to that in 1997?
Your response must be concise. 0.99. What is the ratio of the Electricity production(% of total) in Turkey in 1995 to that in 1997?
Offer a very short reply. 0.97. What is the ratio of the Electricity production(% of total) of Vietnam in 1995 to that in 1997?
Provide a succinct answer. 0.78. What is the ratio of the Electricity production(% of total) in Guatemala in 1995 to that in 1998?
Give a very brief answer. 0.76. What is the ratio of the Electricity production(% of total) of Iraq in 1995 to that in 1998?
Your answer should be very brief. 0.97. What is the ratio of the Electricity production(% of total) of Turkey in 1995 to that in 1998?
Your response must be concise. 0.94. What is the ratio of the Electricity production(% of total) of Vietnam in 1995 to that in 1998?
Provide a short and direct response. 0.52. What is the ratio of the Electricity production(% of total) of Guatemala in 1995 to that in 1999?
Offer a very short reply. 0.79. What is the ratio of the Electricity production(% of total) of Iraq in 1995 to that in 1999?
Offer a very short reply. 0.99. What is the ratio of the Electricity production(% of total) of Turkey in 1995 to that in 1999?
Provide a succinct answer. 0.96. What is the ratio of the Electricity production(% of total) of Vietnam in 1995 to that in 1999?
Give a very brief answer. 0.64. What is the ratio of the Electricity production(% of total) in Guatemala in 1995 to that in 2000?
Provide a short and direct response. 0.85. What is the ratio of the Electricity production(% of total) of Iraq in 1995 to that in 2000?
Your response must be concise. 0.98. What is the ratio of the Electricity production(% of total) of Turkey in 1995 to that in 2000?
Your response must be concise. 0.9. What is the ratio of the Electricity production(% of total) in Vietnam in 1995 to that in 2000?
Provide a short and direct response. 0.52. What is the ratio of the Electricity production(% of total) in Guatemala in 1995 to that in 2001?
Provide a succinct answer. 0.77. What is the ratio of the Electricity production(% of total) of Iraq in 1995 to that in 2001?
Offer a terse response. 0.95. What is the ratio of the Electricity production(% of total) of Turkey in 1995 to that in 2001?
Keep it short and to the point. 0.79. What is the ratio of the Electricity production(% of total) of Vietnam in 1995 to that in 2001?
Give a very brief answer. 0.57. What is the ratio of the Electricity production(% of total) of Guatemala in 1995 to that in 2002?
Make the answer very short. 0.79. What is the ratio of the Electricity production(% of total) of Iraq in 1995 to that in 2002?
Your response must be concise. 0.91. What is the ratio of the Electricity production(% of total) of Turkey in 1995 to that in 2002?
Your answer should be very brief. 0.81. What is the ratio of the Electricity production(% of total) of Vietnam in 1995 to that in 2002?
Provide a succinct answer. 0.72. What is the ratio of the Electricity production(% of total) of Guatemala in 1996 to that in 1997?
Ensure brevity in your answer.  0.99. What is the ratio of the Electricity production(% of total) in Iraq in 1996 to that in 1997?
Give a very brief answer. 0.98. What is the ratio of the Electricity production(% of total) in Vietnam in 1996 to that in 1997?
Ensure brevity in your answer.  0.76. What is the ratio of the Electricity production(% of total) in Guatemala in 1996 to that in 1998?
Your answer should be very brief. 0.71. What is the ratio of the Electricity production(% of total) of Iraq in 1996 to that in 1998?
Provide a succinct answer. 0.97. What is the ratio of the Electricity production(% of total) of Turkey in 1996 to that in 1998?
Keep it short and to the point. 0.97. What is the ratio of the Electricity production(% of total) of Vietnam in 1996 to that in 1998?
Offer a very short reply. 0.51. What is the ratio of the Electricity production(% of total) of Guatemala in 1996 to that in 1999?
Make the answer very short. 0.74. What is the ratio of the Electricity production(% of total) of Iraq in 1996 to that in 1999?
Provide a short and direct response. 0.98. What is the ratio of the Electricity production(% of total) in Turkey in 1996 to that in 1999?
Provide a short and direct response. 0.99. What is the ratio of the Electricity production(% of total) of Vietnam in 1996 to that in 1999?
Provide a short and direct response. 0.62. What is the ratio of the Electricity production(% of total) of Guatemala in 1996 to that in 2000?
Your answer should be compact. 0.8. What is the ratio of the Electricity production(% of total) of Iraq in 1996 to that in 2000?
Keep it short and to the point. 0.98. What is the ratio of the Electricity production(% of total) in Turkey in 1996 to that in 2000?
Provide a short and direct response. 0.93. What is the ratio of the Electricity production(% of total) of Vietnam in 1996 to that in 2000?
Ensure brevity in your answer.  0.51. What is the ratio of the Electricity production(% of total) in Guatemala in 1996 to that in 2001?
Your answer should be very brief. 0.72. What is the ratio of the Electricity production(% of total) of Iraq in 1996 to that in 2001?
Your answer should be very brief. 0.95. What is the ratio of the Electricity production(% of total) in Turkey in 1996 to that in 2001?
Offer a very short reply. 0.82. What is the ratio of the Electricity production(% of total) in Vietnam in 1996 to that in 2001?
Your answer should be very brief. 0.56. What is the ratio of the Electricity production(% of total) in Guatemala in 1996 to that in 2002?
Your response must be concise. 0.74. What is the ratio of the Electricity production(% of total) in Iraq in 1996 to that in 2002?
Provide a succinct answer. 0.91. What is the ratio of the Electricity production(% of total) of Turkey in 1996 to that in 2002?
Offer a terse response. 0.83. What is the ratio of the Electricity production(% of total) of Vietnam in 1996 to that in 2002?
Your answer should be very brief. 0.7. What is the ratio of the Electricity production(% of total) of Guatemala in 1997 to that in 1998?
Provide a short and direct response. 0.72. What is the ratio of the Electricity production(% of total) of Iraq in 1997 to that in 1998?
Give a very brief answer. 0.99. What is the ratio of the Electricity production(% of total) in Turkey in 1997 to that in 1998?
Provide a succinct answer. 0.97. What is the ratio of the Electricity production(% of total) of Vietnam in 1997 to that in 1998?
Give a very brief answer. 0.67. What is the ratio of the Electricity production(% of total) of Guatemala in 1997 to that in 1999?
Offer a very short reply. 0.75. What is the ratio of the Electricity production(% of total) of Iraq in 1997 to that in 1999?
Give a very brief answer. 1. What is the ratio of the Electricity production(% of total) in Turkey in 1997 to that in 1999?
Provide a succinct answer. 1. What is the ratio of the Electricity production(% of total) of Vietnam in 1997 to that in 1999?
Provide a short and direct response. 0.82. What is the ratio of the Electricity production(% of total) of Guatemala in 1997 to that in 2000?
Give a very brief answer. 0.81. What is the ratio of the Electricity production(% of total) of Turkey in 1997 to that in 2000?
Provide a succinct answer. 0.93. What is the ratio of the Electricity production(% of total) of Vietnam in 1997 to that in 2000?
Provide a succinct answer. 0.67. What is the ratio of the Electricity production(% of total) in Guatemala in 1997 to that in 2001?
Make the answer very short. 0.73. What is the ratio of the Electricity production(% of total) in Iraq in 1997 to that in 2001?
Offer a very short reply. 0.97. What is the ratio of the Electricity production(% of total) of Turkey in 1997 to that in 2001?
Give a very brief answer. 0.82. What is the ratio of the Electricity production(% of total) in Vietnam in 1997 to that in 2001?
Provide a succinct answer. 0.73. What is the ratio of the Electricity production(% of total) of Guatemala in 1997 to that in 2002?
Keep it short and to the point. 0.75. What is the ratio of the Electricity production(% of total) of Iraq in 1997 to that in 2002?
Your answer should be compact. 0.93. What is the ratio of the Electricity production(% of total) of Turkey in 1997 to that in 2002?
Make the answer very short. 0.83. What is the ratio of the Electricity production(% of total) in Vietnam in 1997 to that in 2002?
Give a very brief answer. 0.93. What is the ratio of the Electricity production(% of total) in Guatemala in 1998 to that in 1999?
Give a very brief answer. 1.05. What is the ratio of the Electricity production(% of total) in Iraq in 1998 to that in 1999?
Keep it short and to the point. 1.01. What is the ratio of the Electricity production(% of total) of Turkey in 1998 to that in 1999?
Offer a terse response. 1.03. What is the ratio of the Electricity production(% of total) in Vietnam in 1998 to that in 1999?
Ensure brevity in your answer.  1.22. What is the ratio of the Electricity production(% of total) of Guatemala in 1998 to that in 2000?
Provide a succinct answer. 1.12. What is the ratio of the Electricity production(% of total) of Iraq in 1998 to that in 2000?
Provide a succinct answer. 1.01. What is the ratio of the Electricity production(% of total) in Turkey in 1998 to that in 2000?
Your response must be concise. 0.96. What is the ratio of the Electricity production(% of total) in Guatemala in 1998 to that in 2001?
Provide a succinct answer. 1.02. What is the ratio of the Electricity production(% of total) in Iraq in 1998 to that in 2001?
Your answer should be very brief. 0.98. What is the ratio of the Electricity production(% of total) of Turkey in 1998 to that in 2001?
Offer a terse response. 0.84. What is the ratio of the Electricity production(% of total) in Vietnam in 1998 to that in 2001?
Give a very brief answer. 1.09. What is the ratio of the Electricity production(% of total) in Guatemala in 1998 to that in 2002?
Your response must be concise. 1.04. What is the ratio of the Electricity production(% of total) in Iraq in 1998 to that in 2002?
Your response must be concise. 0.94. What is the ratio of the Electricity production(% of total) of Turkey in 1998 to that in 2002?
Offer a terse response. 0.86. What is the ratio of the Electricity production(% of total) of Vietnam in 1998 to that in 2002?
Keep it short and to the point. 1.38. What is the ratio of the Electricity production(% of total) in Guatemala in 1999 to that in 2000?
Your response must be concise. 1.07. What is the ratio of the Electricity production(% of total) in Turkey in 1999 to that in 2000?
Your answer should be very brief. 0.93. What is the ratio of the Electricity production(% of total) in Vietnam in 1999 to that in 2000?
Your response must be concise. 0.82. What is the ratio of the Electricity production(% of total) in Guatemala in 1999 to that in 2001?
Give a very brief answer. 0.97. What is the ratio of the Electricity production(% of total) in Iraq in 1999 to that in 2001?
Your response must be concise. 0.96. What is the ratio of the Electricity production(% of total) of Turkey in 1999 to that in 2001?
Provide a succinct answer. 0.82. What is the ratio of the Electricity production(% of total) in Vietnam in 1999 to that in 2001?
Provide a short and direct response. 0.89. What is the ratio of the Electricity production(% of total) of Iraq in 1999 to that in 2002?
Your answer should be compact. 0.93. What is the ratio of the Electricity production(% of total) of Turkey in 1999 to that in 2002?
Make the answer very short. 0.84. What is the ratio of the Electricity production(% of total) of Vietnam in 1999 to that in 2002?
Make the answer very short. 1.13. What is the ratio of the Electricity production(% of total) of Guatemala in 2000 to that in 2001?
Your answer should be very brief. 0.91. What is the ratio of the Electricity production(% of total) in Iraq in 2000 to that in 2001?
Your response must be concise. 0.97. What is the ratio of the Electricity production(% of total) of Turkey in 2000 to that in 2001?
Offer a terse response. 0.88. What is the ratio of the Electricity production(% of total) in Vietnam in 2000 to that in 2001?
Offer a very short reply. 1.09. What is the ratio of the Electricity production(% of total) in Guatemala in 2000 to that in 2002?
Ensure brevity in your answer.  0.93. What is the ratio of the Electricity production(% of total) in Iraq in 2000 to that in 2002?
Your response must be concise. 0.93. What is the ratio of the Electricity production(% of total) in Turkey in 2000 to that in 2002?
Keep it short and to the point. 0.9. What is the ratio of the Electricity production(% of total) of Vietnam in 2000 to that in 2002?
Provide a succinct answer. 1.39. What is the ratio of the Electricity production(% of total) of Guatemala in 2001 to that in 2002?
Your answer should be very brief. 1.02. What is the ratio of the Electricity production(% of total) in Turkey in 2001 to that in 2002?
Provide a succinct answer. 1.02. What is the ratio of the Electricity production(% of total) in Vietnam in 2001 to that in 2002?
Your response must be concise. 1.27. What is the difference between the highest and the second highest Electricity production(% of total) of Guatemala?
Ensure brevity in your answer.  0.83. What is the difference between the highest and the second highest Electricity production(% of total) of Iraq?
Offer a very short reply. 3.41. What is the difference between the highest and the second highest Electricity production(% of total) of Turkey?
Provide a short and direct response. 0.14. What is the difference between the highest and the second highest Electricity production(% of total) of Vietnam?
Make the answer very short. 0.06. What is the difference between the highest and the lowest Electricity production(% of total) of Guatemala?
Offer a very short reply. 12.92. What is the difference between the highest and the lowest Electricity production(% of total) in Iraq?
Provide a succinct answer. 7.62. What is the difference between the highest and the lowest Electricity production(% of total) of Turkey?
Make the answer very short. 1.75. What is the difference between the highest and the lowest Electricity production(% of total) of Vietnam?
Offer a terse response. 8.38. 